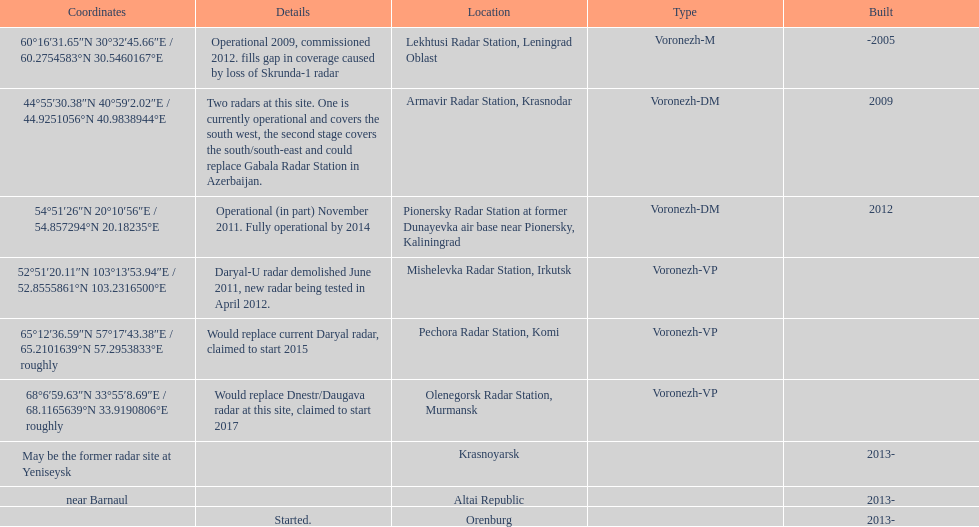How many voronezh radars were built before 2010? 2. 